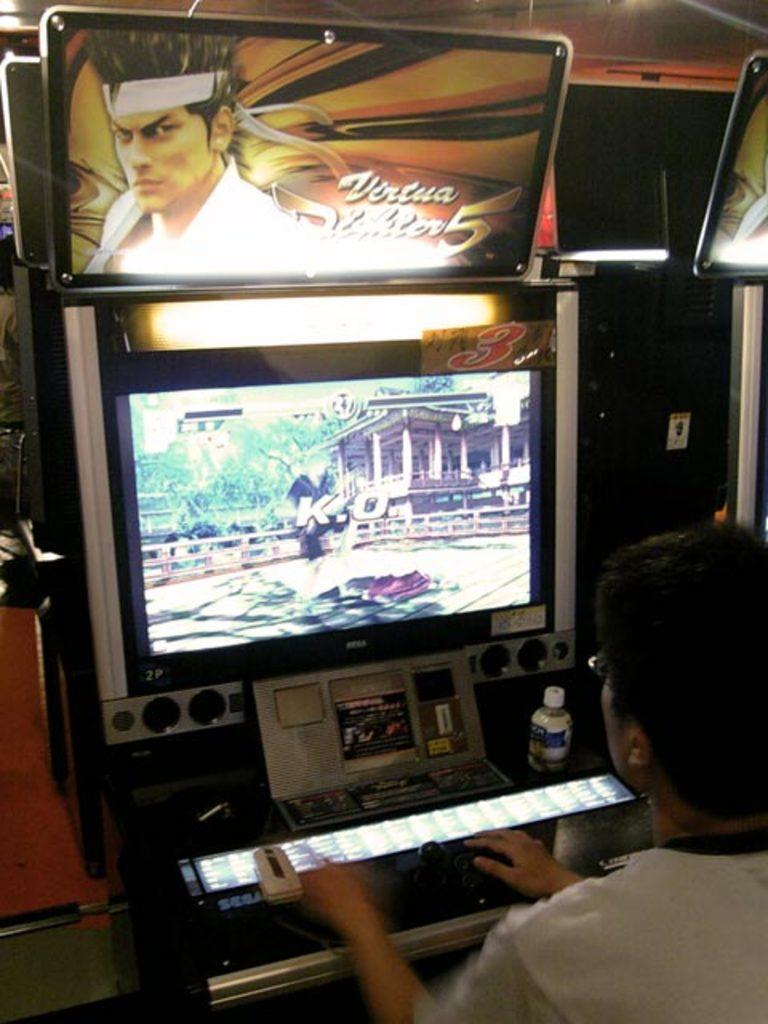Provide a one-sentence caption for the provided image. A man playing a game that has K.O. currently on the screen. 